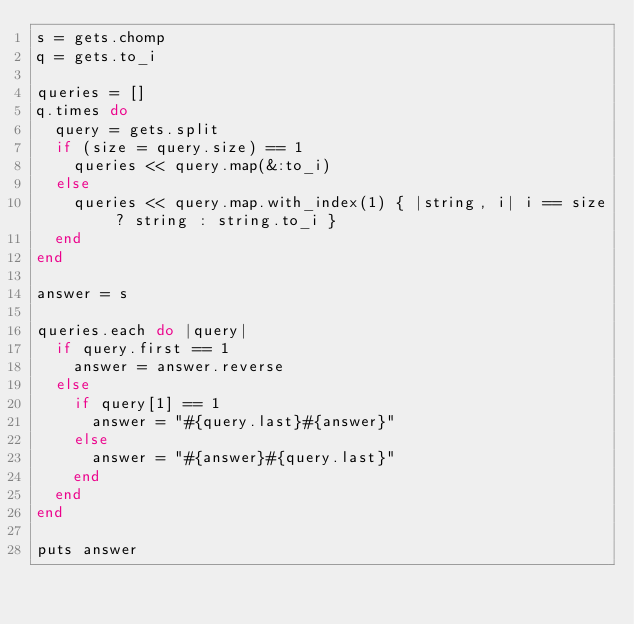<code> <loc_0><loc_0><loc_500><loc_500><_Ruby_>s = gets.chomp
q = gets.to_i

queries = []
q.times do
  query = gets.split
  if (size = query.size) == 1
    queries << query.map(&:to_i)
  else
    queries << query.map.with_index(1) { |string, i| i == size ? string : string.to_i }
  end
end

answer = s

queries.each do |query|
  if query.first == 1
    answer = answer.reverse
  else
    if query[1] == 1
      answer = "#{query.last}#{answer}"
    else
      answer = "#{answer}#{query.last}"
    end
  end
end

puts answer
</code> 